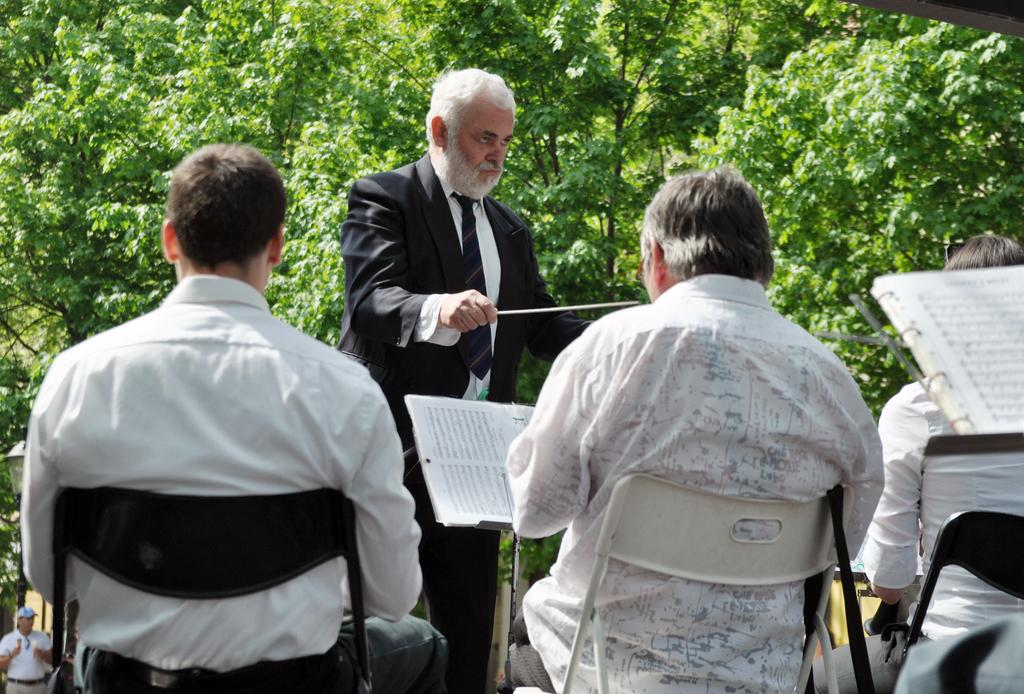What are the people in the image doing? The people in the image are sitting on chairs. What objects are in front of the people sitting on chairs? There are books in front of the people sitting on chairs. Can you describe the person in the background of the image? There is a person standing in the background of the image. What can be seen in the distance behind the people in the image? There are trees visible in the background of the image. What shape is the horse in the image? There is no horse present in the image. 